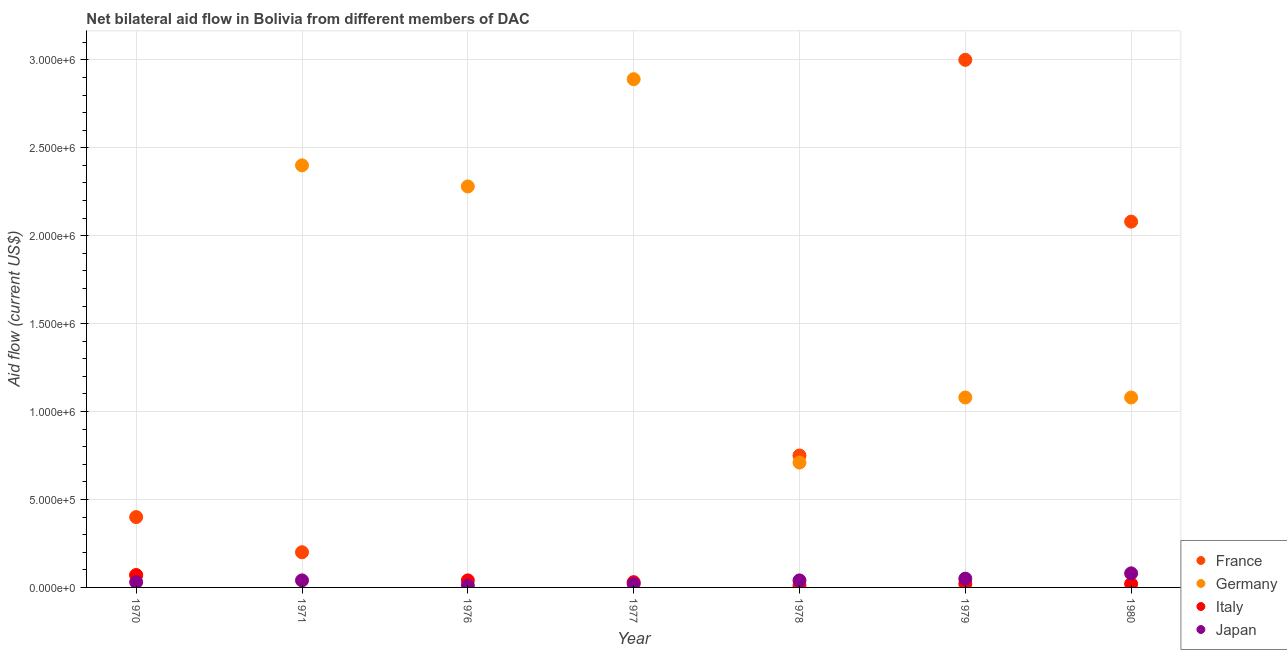How many different coloured dotlines are there?
Your response must be concise. 4. What is the amount of aid given by japan in 1980?
Your answer should be very brief. 8.00e+04. Across all years, what is the maximum amount of aid given by italy?
Your answer should be compact. 7.00e+04. Across all years, what is the minimum amount of aid given by germany?
Provide a succinct answer. 7.00e+04. What is the total amount of aid given by italy in the graph?
Your response must be concise. 1.90e+05. What is the difference between the amount of aid given by japan in 1970 and that in 1971?
Your answer should be compact. -10000. What is the difference between the amount of aid given by germany in 1980 and the amount of aid given by japan in 1971?
Your response must be concise. 1.04e+06. What is the average amount of aid given by italy per year?
Provide a succinct answer. 2.71e+04. In the year 1980, what is the difference between the amount of aid given by germany and amount of aid given by france?
Offer a very short reply. -1.00e+06. What is the ratio of the amount of aid given by japan in 1976 to that in 1979?
Provide a succinct answer. 0.2. What is the difference between the highest and the lowest amount of aid given by france?
Offer a terse response. 3.00e+06. In how many years, is the amount of aid given by france greater than the average amount of aid given by france taken over all years?
Your response must be concise. 2. Is the amount of aid given by france strictly less than the amount of aid given by japan over the years?
Offer a terse response. No. How many dotlines are there?
Keep it short and to the point. 4. How many years are there in the graph?
Your answer should be compact. 7. Are the values on the major ticks of Y-axis written in scientific E-notation?
Make the answer very short. Yes. Does the graph contain any zero values?
Provide a short and direct response. Yes. Where does the legend appear in the graph?
Your response must be concise. Bottom right. How many legend labels are there?
Give a very brief answer. 4. How are the legend labels stacked?
Give a very brief answer. Vertical. What is the title of the graph?
Keep it short and to the point. Net bilateral aid flow in Bolivia from different members of DAC. Does "Secondary vocational" appear as one of the legend labels in the graph?
Ensure brevity in your answer.  No. What is the label or title of the X-axis?
Your answer should be very brief. Year. What is the Aid flow (current US$) of Germany in 1970?
Offer a terse response. 7.00e+04. What is the Aid flow (current US$) of France in 1971?
Make the answer very short. 2.00e+05. What is the Aid flow (current US$) in Germany in 1971?
Keep it short and to the point. 2.40e+06. What is the Aid flow (current US$) of Japan in 1971?
Keep it short and to the point. 4.00e+04. What is the Aid flow (current US$) of Germany in 1976?
Ensure brevity in your answer.  2.28e+06. What is the Aid flow (current US$) of Japan in 1976?
Give a very brief answer. 10000. What is the Aid flow (current US$) of France in 1977?
Your answer should be compact. 0. What is the Aid flow (current US$) in Germany in 1977?
Provide a short and direct response. 2.89e+06. What is the Aid flow (current US$) in Italy in 1977?
Your answer should be very brief. 3.00e+04. What is the Aid flow (current US$) in France in 1978?
Your response must be concise. 7.50e+05. What is the Aid flow (current US$) of Germany in 1978?
Your response must be concise. 7.10e+05. What is the Aid flow (current US$) in Japan in 1978?
Make the answer very short. 4.00e+04. What is the Aid flow (current US$) in Germany in 1979?
Keep it short and to the point. 1.08e+06. What is the Aid flow (current US$) of Italy in 1979?
Offer a very short reply. 2.00e+04. What is the Aid flow (current US$) of France in 1980?
Provide a succinct answer. 2.08e+06. What is the Aid flow (current US$) in Germany in 1980?
Offer a very short reply. 1.08e+06. What is the Aid flow (current US$) in Italy in 1980?
Provide a succinct answer. 2.00e+04. What is the Aid flow (current US$) of Japan in 1980?
Offer a terse response. 8.00e+04. Across all years, what is the maximum Aid flow (current US$) of France?
Ensure brevity in your answer.  3.00e+06. Across all years, what is the maximum Aid flow (current US$) in Germany?
Your answer should be very brief. 2.89e+06. Across all years, what is the maximum Aid flow (current US$) of Italy?
Give a very brief answer. 7.00e+04. Across all years, what is the maximum Aid flow (current US$) of Japan?
Make the answer very short. 8.00e+04. Across all years, what is the minimum Aid flow (current US$) in France?
Your answer should be compact. 0. What is the total Aid flow (current US$) in France in the graph?
Your answer should be very brief. 6.43e+06. What is the total Aid flow (current US$) of Germany in the graph?
Your answer should be very brief. 1.05e+07. What is the total Aid flow (current US$) of Italy in the graph?
Give a very brief answer. 1.90e+05. What is the difference between the Aid flow (current US$) in Germany in 1970 and that in 1971?
Make the answer very short. -2.33e+06. What is the difference between the Aid flow (current US$) of Japan in 1970 and that in 1971?
Offer a very short reply. -10000. What is the difference between the Aid flow (current US$) in Germany in 1970 and that in 1976?
Give a very brief answer. -2.21e+06. What is the difference between the Aid flow (current US$) of Germany in 1970 and that in 1977?
Provide a short and direct response. -2.82e+06. What is the difference between the Aid flow (current US$) of Japan in 1970 and that in 1977?
Ensure brevity in your answer.  10000. What is the difference between the Aid flow (current US$) of France in 1970 and that in 1978?
Provide a short and direct response. -3.50e+05. What is the difference between the Aid flow (current US$) in Germany in 1970 and that in 1978?
Your answer should be compact. -6.40e+05. What is the difference between the Aid flow (current US$) in Japan in 1970 and that in 1978?
Provide a short and direct response. -10000. What is the difference between the Aid flow (current US$) in France in 1970 and that in 1979?
Your answer should be compact. -2.60e+06. What is the difference between the Aid flow (current US$) in Germany in 1970 and that in 1979?
Offer a terse response. -1.01e+06. What is the difference between the Aid flow (current US$) in Japan in 1970 and that in 1979?
Provide a succinct answer. -2.00e+04. What is the difference between the Aid flow (current US$) of France in 1970 and that in 1980?
Provide a succinct answer. -1.68e+06. What is the difference between the Aid flow (current US$) of Germany in 1970 and that in 1980?
Your answer should be compact. -1.01e+06. What is the difference between the Aid flow (current US$) in Germany in 1971 and that in 1976?
Provide a short and direct response. 1.20e+05. What is the difference between the Aid flow (current US$) in Japan in 1971 and that in 1976?
Your response must be concise. 3.00e+04. What is the difference between the Aid flow (current US$) in Germany in 1971 and that in 1977?
Your answer should be compact. -4.90e+05. What is the difference between the Aid flow (current US$) of Japan in 1971 and that in 1977?
Offer a terse response. 2.00e+04. What is the difference between the Aid flow (current US$) in France in 1971 and that in 1978?
Provide a short and direct response. -5.50e+05. What is the difference between the Aid flow (current US$) of Germany in 1971 and that in 1978?
Your answer should be compact. 1.69e+06. What is the difference between the Aid flow (current US$) in Japan in 1971 and that in 1978?
Offer a terse response. 0. What is the difference between the Aid flow (current US$) in France in 1971 and that in 1979?
Keep it short and to the point. -2.80e+06. What is the difference between the Aid flow (current US$) in Germany in 1971 and that in 1979?
Your answer should be very brief. 1.32e+06. What is the difference between the Aid flow (current US$) of Japan in 1971 and that in 1979?
Ensure brevity in your answer.  -10000. What is the difference between the Aid flow (current US$) in France in 1971 and that in 1980?
Make the answer very short. -1.88e+06. What is the difference between the Aid flow (current US$) in Germany in 1971 and that in 1980?
Offer a terse response. 1.32e+06. What is the difference between the Aid flow (current US$) of Germany in 1976 and that in 1977?
Offer a very short reply. -6.10e+05. What is the difference between the Aid flow (current US$) in Italy in 1976 and that in 1977?
Keep it short and to the point. 10000. What is the difference between the Aid flow (current US$) of Japan in 1976 and that in 1977?
Make the answer very short. -10000. What is the difference between the Aid flow (current US$) in Germany in 1976 and that in 1978?
Your answer should be compact. 1.57e+06. What is the difference between the Aid flow (current US$) in Japan in 1976 and that in 1978?
Ensure brevity in your answer.  -3.00e+04. What is the difference between the Aid flow (current US$) of Germany in 1976 and that in 1979?
Your response must be concise. 1.20e+06. What is the difference between the Aid flow (current US$) of Germany in 1976 and that in 1980?
Your answer should be very brief. 1.20e+06. What is the difference between the Aid flow (current US$) in Italy in 1976 and that in 1980?
Offer a terse response. 2.00e+04. What is the difference between the Aid flow (current US$) in Japan in 1976 and that in 1980?
Provide a short and direct response. -7.00e+04. What is the difference between the Aid flow (current US$) in Germany in 1977 and that in 1978?
Offer a terse response. 2.18e+06. What is the difference between the Aid flow (current US$) in Germany in 1977 and that in 1979?
Your response must be concise. 1.81e+06. What is the difference between the Aid flow (current US$) of Italy in 1977 and that in 1979?
Keep it short and to the point. 10000. What is the difference between the Aid flow (current US$) in Germany in 1977 and that in 1980?
Make the answer very short. 1.81e+06. What is the difference between the Aid flow (current US$) in Japan in 1977 and that in 1980?
Your answer should be very brief. -6.00e+04. What is the difference between the Aid flow (current US$) of France in 1978 and that in 1979?
Make the answer very short. -2.25e+06. What is the difference between the Aid flow (current US$) in Germany in 1978 and that in 1979?
Offer a very short reply. -3.70e+05. What is the difference between the Aid flow (current US$) of Japan in 1978 and that in 1979?
Offer a very short reply. -10000. What is the difference between the Aid flow (current US$) in France in 1978 and that in 1980?
Provide a succinct answer. -1.33e+06. What is the difference between the Aid flow (current US$) in Germany in 1978 and that in 1980?
Provide a short and direct response. -3.70e+05. What is the difference between the Aid flow (current US$) of France in 1979 and that in 1980?
Ensure brevity in your answer.  9.20e+05. What is the difference between the Aid flow (current US$) in Germany in 1979 and that in 1980?
Your response must be concise. 0. What is the difference between the Aid flow (current US$) of Japan in 1979 and that in 1980?
Offer a very short reply. -3.00e+04. What is the difference between the Aid flow (current US$) of Germany in 1970 and the Aid flow (current US$) of Japan in 1971?
Provide a succinct answer. 3.00e+04. What is the difference between the Aid flow (current US$) in France in 1970 and the Aid flow (current US$) in Germany in 1976?
Offer a terse response. -1.88e+06. What is the difference between the Aid flow (current US$) in France in 1970 and the Aid flow (current US$) in Japan in 1976?
Keep it short and to the point. 3.90e+05. What is the difference between the Aid flow (current US$) in Italy in 1970 and the Aid flow (current US$) in Japan in 1976?
Your answer should be very brief. 6.00e+04. What is the difference between the Aid flow (current US$) in France in 1970 and the Aid flow (current US$) in Germany in 1977?
Keep it short and to the point. -2.49e+06. What is the difference between the Aid flow (current US$) in Germany in 1970 and the Aid flow (current US$) in Italy in 1977?
Ensure brevity in your answer.  4.00e+04. What is the difference between the Aid flow (current US$) of Germany in 1970 and the Aid flow (current US$) of Japan in 1977?
Ensure brevity in your answer.  5.00e+04. What is the difference between the Aid flow (current US$) of France in 1970 and the Aid flow (current US$) of Germany in 1978?
Your response must be concise. -3.10e+05. What is the difference between the Aid flow (current US$) in France in 1970 and the Aid flow (current US$) in Japan in 1978?
Provide a succinct answer. 3.60e+05. What is the difference between the Aid flow (current US$) of France in 1970 and the Aid flow (current US$) of Germany in 1979?
Your response must be concise. -6.80e+05. What is the difference between the Aid flow (current US$) in Germany in 1970 and the Aid flow (current US$) in Italy in 1979?
Offer a terse response. 5.00e+04. What is the difference between the Aid flow (current US$) in Italy in 1970 and the Aid flow (current US$) in Japan in 1979?
Give a very brief answer. 2.00e+04. What is the difference between the Aid flow (current US$) in France in 1970 and the Aid flow (current US$) in Germany in 1980?
Your answer should be compact. -6.80e+05. What is the difference between the Aid flow (current US$) of France in 1970 and the Aid flow (current US$) of Italy in 1980?
Your answer should be compact. 3.80e+05. What is the difference between the Aid flow (current US$) in France in 1971 and the Aid flow (current US$) in Germany in 1976?
Your answer should be very brief. -2.08e+06. What is the difference between the Aid flow (current US$) in France in 1971 and the Aid flow (current US$) in Japan in 1976?
Keep it short and to the point. 1.90e+05. What is the difference between the Aid flow (current US$) of Germany in 1971 and the Aid flow (current US$) of Italy in 1976?
Provide a succinct answer. 2.36e+06. What is the difference between the Aid flow (current US$) in Germany in 1971 and the Aid flow (current US$) in Japan in 1976?
Your answer should be very brief. 2.39e+06. What is the difference between the Aid flow (current US$) in France in 1971 and the Aid flow (current US$) in Germany in 1977?
Offer a terse response. -2.69e+06. What is the difference between the Aid flow (current US$) of France in 1971 and the Aid flow (current US$) of Italy in 1977?
Keep it short and to the point. 1.70e+05. What is the difference between the Aid flow (current US$) in Germany in 1971 and the Aid flow (current US$) in Italy in 1977?
Ensure brevity in your answer.  2.37e+06. What is the difference between the Aid flow (current US$) of Germany in 1971 and the Aid flow (current US$) of Japan in 1977?
Your answer should be very brief. 2.38e+06. What is the difference between the Aid flow (current US$) of France in 1971 and the Aid flow (current US$) of Germany in 1978?
Give a very brief answer. -5.10e+05. What is the difference between the Aid flow (current US$) of France in 1971 and the Aid flow (current US$) of Italy in 1978?
Your answer should be very brief. 1.90e+05. What is the difference between the Aid flow (current US$) in Germany in 1971 and the Aid flow (current US$) in Italy in 1978?
Make the answer very short. 2.39e+06. What is the difference between the Aid flow (current US$) of Germany in 1971 and the Aid flow (current US$) of Japan in 1978?
Provide a short and direct response. 2.36e+06. What is the difference between the Aid flow (current US$) in France in 1971 and the Aid flow (current US$) in Germany in 1979?
Offer a terse response. -8.80e+05. What is the difference between the Aid flow (current US$) of France in 1971 and the Aid flow (current US$) of Japan in 1979?
Give a very brief answer. 1.50e+05. What is the difference between the Aid flow (current US$) in Germany in 1971 and the Aid flow (current US$) in Italy in 1979?
Give a very brief answer. 2.38e+06. What is the difference between the Aid flow (current US$) in Germany in 1971 and the Aid flow (current US$) in Japan in 1979?
Your answer should be very brief. 2.35e+06. What is the difference between the Aid flow (current US$) in France in 1971 and the Aid flow (current US$) in Germany in 1980?
Provide a short and direct response. -8.80e+05. What is the difference between the Aid flow (current US$) of France in 1971 and the Aid flow (current US$) of Italy in 1980?
Keep it short and to the point. 1.80e+05. What is the difference between the Aid flow (current US$) in Germany in 1971 and the Aid flow (current US$) in Italy in 1980?
Keep it short and to the point. 2.38e+06. What is the difference between the Aid flow (current US$) in Germany in 1971 and the Aid flow (current US$) in Japan in 1980?
Your answer should be very brief. 2.32e+06. What is the difference between the Aid flow (current US$) of Germany in 1976 and the Aid flow (current US$) of Italy in 1977?
Make the answer very short. 2.25e+06. What is the difference between the Aid flow (current US$) of Germany in 1976 and the Aid flow (current US$) of Japan in 1977?
Your answer should be very brief. 2.26e+06. What is the difference between the Aid flow (current US$) in Germany in 1976 and the Aid flow (current US$) in Italy in 1978?
Give a very brief answer. 2.27e+06. What is the difference between the Aid flow (current US$) in Germany in 1976 and the Aid flow (current US$) in Japan in 1978?
Provide a short and direct response. 2.24e+06. What is the difference between the Aid flow (current US$) of Italy in 1976 and the Aid flow (current US$) of Japan in 1978?
Provide a succinct answer. 0. What is the difference between the Aid flow (current US$) of Germany in 1976 and the Aid flow (current US$) of Italy in 1979?
Provide a short and direct response. 2.26e+06. What is the difference between the Aid flow (current US$) in Germany in 1976 and the Aid flow (current US$) in Japan in 1979?
Offer a very short reply. 2.23e+06. What is the difference between the Aid flow (current US$) in Italy in 1976 and the Aid flow (current US$) in Japan in 1979?
Offer a very short reply. -10000. What is the difference between the Aid flow (current US$) of Germany in 1976 and the Aid flow (current US$) of Italy in 1980?
Ensure brevity in your answer.  2.26e+06. What is the difference between the Aid flow (current US$) in Germany in 1976 and the Aid flow (current US$) in Japan in 1980?
Your answer should be compact. 2.20e+06. What is the difference between the Aid flow (current US$) in Germany in 1977 and the Aid flow (current US$) in Italy in 1978?
Ensure brevity in your answer.  2.88e+06. What is the difference between the Aid flow (current US$) of Germany in 1977 and the Aid flow (current US$) of Japan in 1978?
Make the answer very short. 2.85e+06. What is the difference between the Aid flow (current US$) of Italy in 1977 and the Aid flow (current US$) of Japan in 1978?
Offer a terse response. -10000. What is the difference between the Aid flow (current US$) in Germany in 1977 and the Aid flow (current US$) in Italy in 1979?
Make the answer very short. 2.87e+06. What is the difference between the Aid flow (current US$) of Germany in 1977 and the Aid flow (current US$) of Japan in 1979?
Offer a very short reply. 2.84e+06. What is the difference between the Aid flow (current US$) of Italy in 1977 and the Aid flow (current US$) of Japan in 1979?
Provide a succinct answer. -2.00e+04. What is the difference between the Aid flow (current US$) of Germany in 1977 and the Aid flow (current US$) of Italy in 1980?
Your answer should be very brief. 2.87e+06. What is the difference between the Aid flow (current US$) of Germany in 1977 and the Aid flow (current US$) of Japan in 1980?
Give a very brief answer. 2.81e+06. What is the difference between the Aid flow (current US$) in Italy in 1977 and the Aid flow (current US$) in Japan in 1980?
Provide a succinct answer. -5.00e+04. What is the difference between the Aid flow (current US$) in France in 1978 and the Aid flow (current US$) in Germany in 1979?
Offer a very short reply. -3.30e+05. What is the difference between the Aid flow (current US$) in France in 1978 and the Aid flow (current US$) in Italy in 1979?
Give a very brief answer. 7.30e+05. What is the difference between the Aid flow (current US$) in Germany in 1978 and the Aid flow (current US$) in Italy in 1979?
Make the answer very short. 6.90e+05. What is the difference between the Aid flow (current US$) in France in 1978 and the Aid flow (current US$) in Germany in 1980?
Offer a very short reply. -3.30e+05. What is the difference between the Aid flow (current US$) of France in 1978 and the Aid flow (current US$) of Italy in 1980?
Give a very brief answer. 7.30e+05. What is the difference between the Aid flow (current US$) in France in 1978 and the Aid flow (current US$) in Japan in 1980?
Your answer should be very brief. 6.70e+05. What is the difference between the Aid flow (current US$) in Germany in 1978 and the Aid flow (current US$) in Italy in 1980?
Your answer should be very brief. 6.90e+05. What is the difference between the Aid flow (current US$) of Germany in 1978 and the Aid flow (current US$) of Japan in 1980?
Your response must be concise. 6.30e+05. What is the difference between the Aid flow (current US$) of Italy in 1978 and the Aid flow (current US$) of Japan in 1980?
Give a very brief answer. -7.00e+04. What is the difference between the Aid flow (current US$) of France in 1979 and the Aid flow (current US$) of Germany in 1980?
Provide a short and direct response. 1.92e+06. What is the difference between the Aid flow (current US$) in France in 1979 and the Aid flow (current US$) in Italy in 1980?
Offer a very short reply. 2.98e+06. What is the difference between the Aid flow (current US$) in France in 1979 and the Aid flow (current US$) in Japan in 1980?
Give a very brief answer. 2.92e+06. What is the difference between the Aid flow (current US$) in Germany in 1979 and the Aid flow (current US$) in Italy in 1980?
Ensure brevity in your answer.  1.06e+06. What is the average Aid flow (current US$) in France per year?
Give a very brief answer. 9.19e+05. What is the average Aid flow (current US$) of Germany per year?
Provide a succinct answer. 1.50e+06. What is the average Aid flow (current US$) of Italy per year?
Offer a very short reply. 2.71e+04. What is the average Aid flow (current US$) in Japan per year?
Keep it short and to the point. 3.86e+04. In the year 1970, what is the difference between the Aid flow (current US$) of France and Aid flow (current US$) of Germany?
Ensure brevity in your answer.  3.30e+05. In the year 1970, what is the difference between the Aid flow (current US$) in France and Aid flow (current US$) in Italy?
Ensure brevity in your answer.  3.30e+05. In the year 1970, what is the difference between the Aid flow (current US$) in Germany and Aid flow (current US$) in Italy?
Make the answer very short. 0. In the year 1970, what is the difference between the Aid flow (current US$) of Germany and Aid flow (current US$) of Japan?
Your response must be concise. 4.00e+04. In the year 1971, what is the difference between the Aid flow (current US$) of France and Aid flow (current US$) of Germany?
Ensure brevity in your answer.  -2.20e+06. In the year 1971, what is the difference between the Aid flow (current US$) in Germany and Aid flow (current US$) in Japan?
Offer a terse response. 2.36e+06. In the year 1976, what is the difference between the Aid flow (current US$) of Germany and Aid flow (current US$) of Italy?
Your answer should be compact. 2.24e+06. In the year 1976, what is the difference between the Aid flow (current US$) in Germany and Aid flow (current US$) in Japan?
Give a very brief answer. 2.27e+06. In the year 1976, what is the difference between the Aid flow (current US$) in Italy and Aid flow (current US$) in Japan?
Make the answer very short. 3.00e+04. In the year 1977, what is the difference between the Aid flow (current US$) of Germany and Aid flow (current US$) of Italy?
Provide a short and direct response. 2.86e+06. In the year 1977, what is the difference between the Aid flow (current US$) in Germany and Aid flow (current US$) in Japan?
Make the answer very short. 2.87e+06. In the year 1977, what is the difference between the Aid flow (current US$) in Italy and Aid flow (current US$) in Japan?
Provide a succinct answer. 10000. In the year 1978, what is the difference between the Aid flow (current US$) of France and Aid flow (current US$) of Italy?
Make the answer very short. 7.40e+05. In the year 1978, what is the difference between the Aid flow (current US$) in France and Aid flow (current US$) in Japan?
Your answer should be very brief. 7.10e+05. In the year 1978, what is the difference between the Aid flow (current US$) of Germany and Aid flow (current US$) of Japan?
Make the answer very short. 6.70e+05. In the year 1978, what is the difference between the Aid flow (current US$) of Italy and Aid flow (current US$) of Japan?
Give a very brief answer. -3.00e+04. In the year 1979, what is the difference between the Aid flow (current US$) in France and Aid flow (current US$) in Germany?
Keep it short and to the point. 1.92e+06. In the year 1979, what is the difference between the Aid flow (current US$) of France and Aid flow (current US$) of Italy?
Ensure brevity in your answer.  2.98e+06. In the year 1979, what is the difference between the Aid flow (current US$) in France and Aid flow (current US$) in Japan?
Your response must be concise. 2.95e+06. In the year 1979, what is the difference between the Aid flow (current US$) in Germany and Aid flow (current US$) in Italy?
Your answer should be very brief. 1.06e+06. In the year 1979, what is the difference between the Aid flow (current US$) in Germany and Aid flow (current US$) in Japan?
Ensure brevity in your answer.  1.03e+06. In the year 1980, what is the difference between the Aid flow (current US$) of France and Aid flow (current US$) of Germany?
Offer a terse response. 1.00e+06. In the year 1980, what is the difference between the Aid flow (current US$) in France and Aid flow (current US$) in Italy?
Offer a terse response. 2.06e+06. In the year 1980, what is the difference between the Aid flow (current US$) in France and Aid flow (current US$) in Japan?
Provide a short and direct response. 2.00e+06. In the year 1980, what is the difference between the Aid flow (current US$) in Germany and Aid flow (current US$) in Italy?
Your answer should be compact. 1.06e+06. What is the ratio of the Aid flow (current US$) of France in 1970 to that in 1971?
Make the answer very short. 2. What is the ratio of the Aid flow (current US$) in Germany in 1970 to that in 1971?
Your response must be concise. 0.03. What is the ratio of the Aid flow (current US$) of Germany in 1970 to that in 1976?
Your response must be concise. 0.03. What is the ratio of the Aid flow (current US$) of Italy in 1970 to that in 1976?
Your answer should be very brief. 1.75. What is the ratio of the Aid flow (current US$) in Germany in 1970 to that in 1977?
Offer a terse response. 0.02. What is the ratio of the Aid flow (current US$) of Italy in 1970 to that in 1977?
Offer a terse response. 2.33. What is the ratio of the Aid flow (current US$) of France in 1970 to that in 1978?
Offer a terse response. 0.53. What is the ratio of the Aid flow (current US$) in Germany in 1970 to that in 1978?
Ensure brevity in your answer.  0.1. What is the ratio of the Aid flow (current US$) in France in 1970 to that in 1979?
Provide a succinct answer. 0.13. What is the ratio of the Aid flow (current US$) in Germany in 1970 to that in 1979?
Your answer should be very brief. 0.06. What is the ratio of the Aid flow (current US$) of Italy in 1970 to that in 1979?
Provide a succinct answer. 3.5. What is the ratio of the Aid flow (current US$) in France in 1970 to that in 1980?
Offer a very short reply. 0.19. What is the ratio of the Aid flow (current US$) of Germany in 1970 to that in 1980?
Your answer should be very brief. 0.06. What is the ratio of the Aid flow (current US$) in Japan in 1970 to that in 1980?
Offer a very short reply. 0.38. What is the ratio of the Aid flow (current US$) of Germany in 1971 to that in 1976?
Your answer should be compact. 1.05. What is the ratio of the Aid flow (current US$) in Japan in 1971 to that in 1976?
Offer a very short reply. 4. What is the ratio of the Aid flow (current US$) in Germany in 1971 to that in 1977?
Give a very brief answer. 0.83. What is the ratio of the Aid flow (current US$) in Japan in 1971 to that in 1977?
Your answer should be very brief. 2. What is the ratio of the Aid flow (current US$) of France in 1971 to that in 1978?
Keep it short and to the point. 0.27. What is the ratio of the Aid flow (current US$) of Germany in 1971 to that in 1978?
Offer a very short reply. 3.38. What is the ratio of the Aid flow (current US$) in Japan in 1971 to that in 1978?
Provide a short and direct response. 1. What is the ratio of the Aid flow (current US$) of France in 1971 to that in 1979?
Your answer should be very brief. 0.07. What is the ratio of the Aid flow (current US$) in Germany in 1971 to that in 1979?
Your answer should be compact. 2.22. What is the ratio of the Aid flow (current US$) of Japan in 1971 to that in 1979?
Your answer should be very brief. 0.8. What is the ratio of the Aid flow (current US$) in France in 1971 to that in 1980?
Make the answer very short. 0.1. What is the ratio of the Aid flow (current US$) of Germany in 1971 to that in 1980?
Your answer should be very brief. 2.22. What is the ratio of the Aid flow (current US$) in Germany in 1976 to that in 1977?
Offer a terse response. 0.79. What is the ratio of the Aid flow (current US$) of Japan in 1976 to that in 1977?
Your response must be concise. 0.5. What is the ratio of the Aid flow (current US$) of Germany in 1976 to that in 1978?
Make the answer very short. 3.21. What is the ratio of the Aid flow (current US$) in Italy in 1976 to that in 1978?
Your response must be concise. 4. What is the ratio of the Aid flow (current US$) of Japan in 1976 to that in 1978?
Give a very brief answer. 0.25. What is the ratio of the Aid flow (current US$) of Germany in 1976 to that in 1979?
Your response must be concise. 2.11. What is the ratio of the Aid flow (current US$) in Italy in 1976 to that in 1979?
Give a very brief answer. 2. What is the ratio of the Aid flow (current US$) in Japan in 1976 to that in 1979?
Ensure brevity in your answer.  0.2. What is the ratio of the Aid flow (current US$) of Germany in 1976 to that in 1980?
Provide a succinct answer. 2.11. What is the ratio of the Aid flow (current US$) in Japan in 1976 to that in 1980?
Keep it short and to the point. 0.12. What is the ratio of the Aid flow (current US$) of Germany in 1977 to that in 1978?
Provide a short and direct response. 4.07. What is the ratio of the Aid flow (current US$) in Italy in 1977 to that in 1978?
Offer a terse response. 3. What is the ratio of the Aid flow (current US$) in Germany in 1977 to that in 1979?
Keep it short and to the point. 2.68. What is the ratio of the Aid flow (current US$) in Japan in 1977 to that in 1979?
Provide a succinct answer. 0.4. What is the ratio of the Aid flow (current US$) of Germany in 1977 to that in 1980?
Your answer should be very brief. 2.68. What is the ratio of the Aid flow (current US$) in Italy in 1977 to that in 1980?
Offer a terse response. 1.5. What is the ratio of the Aid flow (current US$) of France in 1978 to that in 1979?
Give a very brief answer. 0.25. What is the ratio of the Aid flow (current US$) of Germany in 1978 to that in 1979?
Ensure brevity in your answer.  0.66. What is the ratio of the Aid flow (current US$) in Italy in 1978 to that in 1979?
Make the answer very short. 0.5. What is the ratio of the Aid flow (current US$) in Japan in 1978 to that in 1979?
Keep it short and to the point. 0.8. What is the ratio of the Aid flow (current US$) in France in 1978 to that in 1980?
Make the answer very short. 0.36. What is the ratio of the Aid flow (current US$) in Germany in 1978 to that in 1980?
Keep it short and to the point. 0.66. What is the ratio of the Aid flow (current US$) of Japan in 1978 to that in 1980?
Keep it short and to the point. 0.5. What is the ratio of the Aid flow (current US$) of France in 1979 to that in 1980?
Your response must be concise. 1.44. What is the ratio of the Aid flow (current US$) of Germany in 1979 to that in 1980?
Offer a terse response. 1. What is the ratio of the Aid flow (current US$) of Italy in 1979 to that in 1980?
Your answer should be compact. 1. What is the ratio of the Aid flow (current US$) in Japan in 1979 to that in 1980?
Offer a terse response. 0.62. What is the difference between the highest and the second highest Aid flow (current US$) of France?
Your answer should be very brief. 9.20e+05. What is the difference between the highest and the second highest Aid flow (current US$) of Italy?
Provide a short and direct response. 3.00e+04. What is the difference between the highest and the second highest Aid flow (current US$) of Japan?
Make the answer very short. 3.00e+04. What is the difference between the highest and the lowest Aid flow (current US$) of Germany?
Provide a short and direct response. 2.82e+06. 